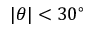<formula> <loc_0><loc_0><loc_500><loc_500>| \theta | < 3 0 ^ { \circ }</formula> 